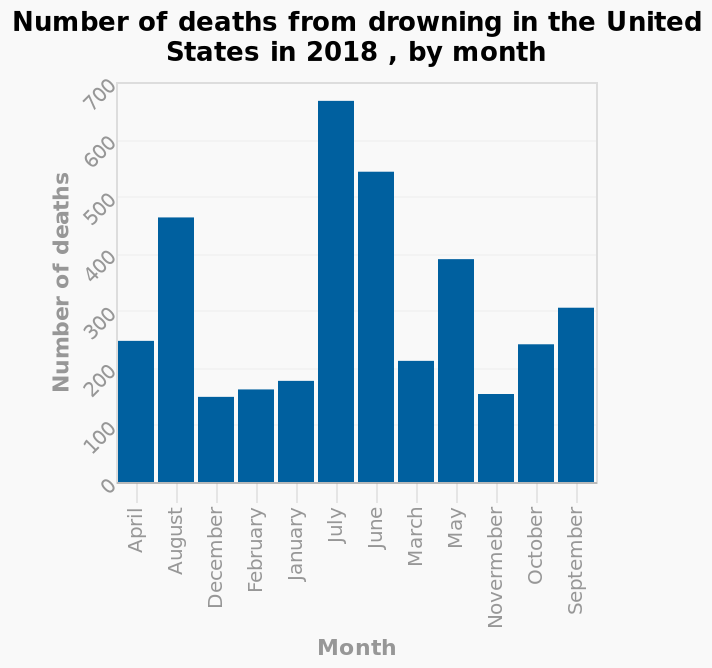<image>
Which year does the data in the bar chart pertain to?  The data in the bar chart pertains to the year 2018. In which month is the risk of drowning the highest?  The risk of drowning is highest in July. What does the bar chart represent?  The bar chart represents the Number of deaths from drowning in the United States in 2018, categorized by month. 